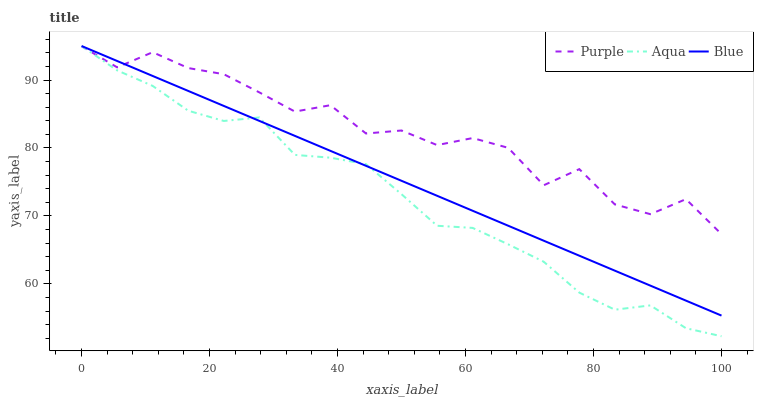Does Aqua have the minimum area under the curve?
Answer yes or no. Yes. Does Purple have the maximum area under the curve?
Answer yes or no. Yes. Does Blue have the minimum area under the curve?
Answer yes or no. No. Does Blue have the maximum area under the curve?
Answer yes or no. No. Is Blue the smoothest?
Answer yes or no. Yes. Is Purple the roughest?
Answer yes or no. Yes. Is Aqua the smoothest?
Answer yes or no. No. Is Aqua the roughest?
Answer yes or no. No. Does Blue have the lowest value?
Answer yes or no. No. Does Aqua have the highest value?
Answer yes or no. Yes. Does Aqua intersect Blue?
Answer yes or no. Yes. Is Aqua less than Blue?
Answer yes or no. No. Is Aqua greater than Blue?
Answer yes or no. No. 